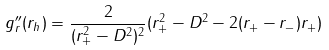Convert formula to latex. <formula><loc_0><loc_0><loc_500><loc_500>g _ { r } ^ { \prime \prime } ( r _ { h } ) = \frac { 2 } { ( r _ { + } ^ { 2 } - D ^ { 2 } ) ^ { 2 } } ( r _ { + } ^ { 2 } - D ^ { 2 } - 2 ( r _ { + } - r _ { - } ) r _ { + } )</formula> 